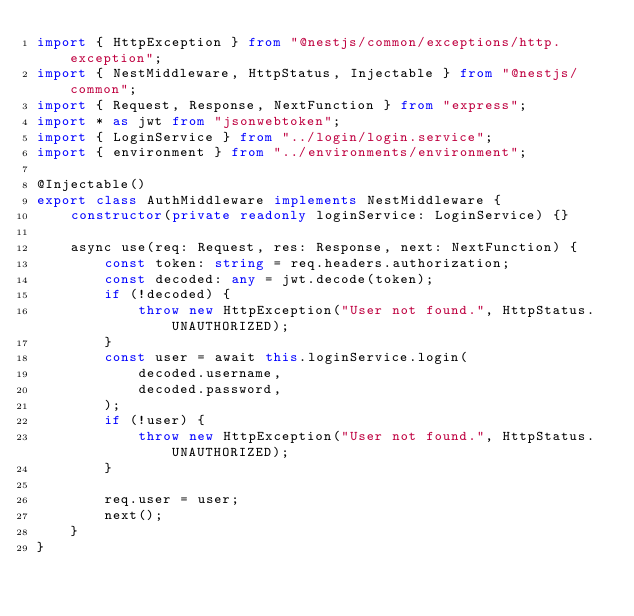<code> <loc_0><loc_0><loc_500><loc_500><_TypeScript_>import { HttpException } from "@nestjs/common/exceptions/http.exception";
import { NestMiddleware, HttpStatus, Injectable } from "@nestjs/common";
import { Request, Response, NextFunction } from "express";
import * as jwt from "jsonwebtoken";
import { LoginService } from "../login/login.service";
import { environment } from "../environments/environment";

@Injectable()
export class AuthMiddleware implements NestMiddleware {
	constructor(private readonly loginService: LoginService) {}

	async use(req: Request, res: Response, next: NextFunction) {
		const token: string = req.headers.authorization;
		const decoded: any = jwt.decode(token);
		if (!decoded) {
			throw new HttpException("User not found.", HttpStatus.UNAUTHORIZED);
		}
		const user = await this.loginService.login(
			decoded.username,
			decoded.password,
		);
		if (!user) {
			throw new HttpException("User not found.", HttpStatus.UNAUTHORIZED);
		}

		req.user = user;
		next();
	}
}
</code> 